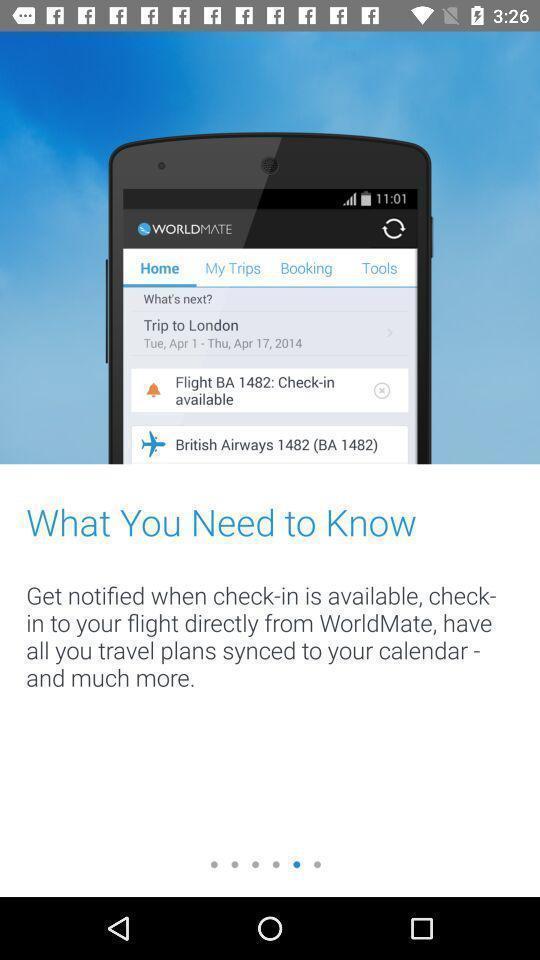Provide a description of this screenshot. Screen displaying the notification about an app. 